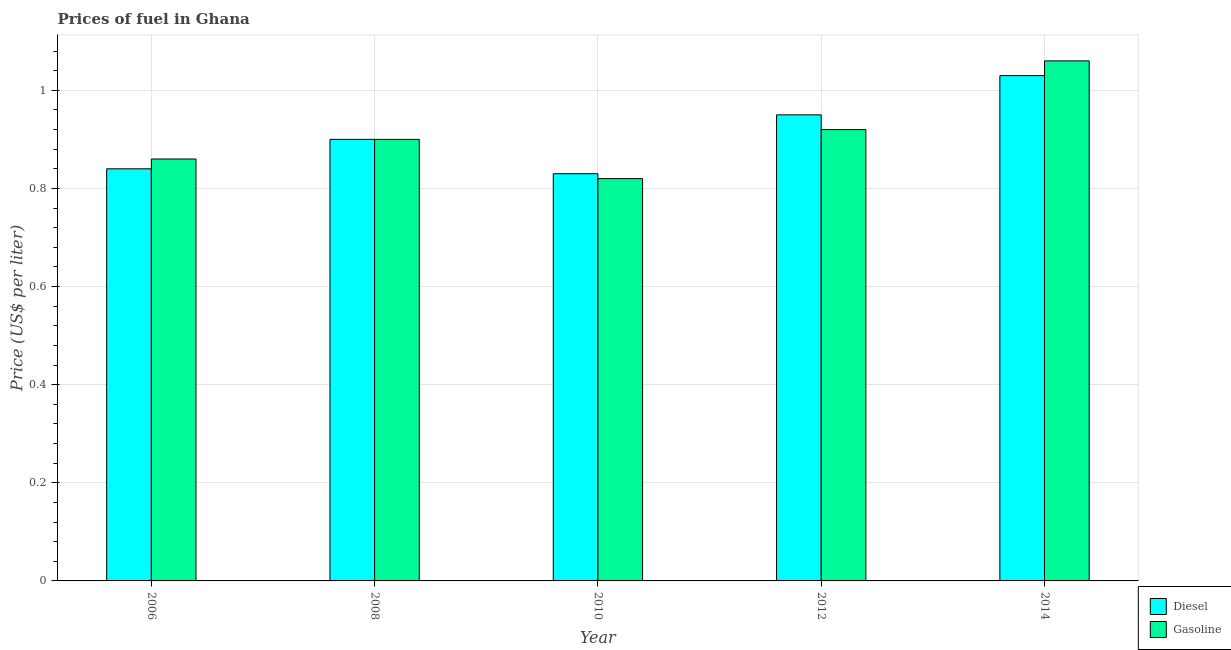Are the number of bars on each tick of the X-axis equal?
Make the answer very short. Yes. How many bars are there on the 2nd tick from the left?
Provide a short and direct response. 2. How many bars are there on the 5th tick from the right?
Your response must be concise. 2. What is the gasoline price in 2014?
Make the answer very short. 1.06. Across all years, what is the maximum gasoline price?
Provide a short and direct response. 1.06. Across all years, what is the minimum gasoline price?
Keep it short and to the point. 0.82. What is the total gasoline price in the graph?
Make the answer very short. 4.56. What is the difference between the diesel price in 2010 and that in 2012?
Ensure brevity in your answer.  -0.12. What is the difference between the gasoline price in 2006 and the diesel price in 2014?
Provide a short and direct response. -0.2. What is the average diesel price per year?
Make the answer very short. 0.91. In the year 2008, what is the difference between the diesel price and gasoline price?
Offer a terse response. 0. What is the ratio of the diesel price in 2010 to that in 2014?
Your response must be concise. 0.81. What is the difference between the highest and the second highest gasoline price?
Your answer should be very brief. 0.14. What is the difference between the highest and the lowest diesel price?
Make the answer very short. 0.2. In how many years, is the diesel price greater than the average diesel price taken over all years?
Offer a terse response. 2. Is the sum of the diesel price in 2012 and 2014 greater than the maximum gasoline price across all years?
Your response must be concise. Yes. What does the 1st bar from the left in 2010 represents?
Provide a short and direct response. Diesel. What does the 1st bar from the right in 2014 represents?
Offer a very short reply. Gasoline. How many bars are there?
Provide a short and direct response. 10. Are all the bars in the graph horizontal?
Make the answer very short. No. Does the graph contain grids?
Your answer should be compact. Yes. Where does the legend appear in the graph?
Offer a terse response. Bottom right. How are the legend labels stacked?
Your response must be concise. Vertical. What is the title of the graph?
Offer a terse response. Prices of fuel in Ghana. Does "Investment in Transport" appear as one of the legend labels in the graph?
Ensure brevity in your answer.  No. What is the label or title of the Y-axis?
Your response must be concise. Price (US$ per liter). What is the Price (US$ per liter) in Diesel in 2006?
Ensure brevity in your answer.  0.84. What is the Price (US$ per liter) in Gasoline in 2006?
Your answer should be compact. 0.86. What is the Price (US$ per liter) in Diesel in 2008?
Keep it short and to the point. 0.9. What is the Price (US$ per liter) in Gasoline in 2008?
Offer a very short reply. 0.9. What is the Price (US$ per liter) in Diesel in 2010?
Provide a short and direct response. 0.83. What is the Price (US$ per liter) of Gasoline in 2010?
Provide a succinct answer. 0.82. What is the Price (US$ per liter) in Gasoline in 2012?
Your answer should be very brief. 0.92. What is the Price (US$ per liter) of Gasoline in 2014?
Your response must be concise. 1.06. Across all years, what is the maximum Price (US$ per liter) in Diesel?
Give a very brief answer. 1.03. Across all years, what is the maximum Price (US$ per liter) of Gasoline?
Ensure brevity in your answer.  1.06. Across all years, what is the minimum Price (US$ per liter) of Diesel?
Provide a short and direct response. 0.83. Across all years, what is the minimum Price (US$ per liter) in Gasoline?
Keep it short and to the point. 0.82. What is the total Price (US$ per liter) in Diesel in the graph?
Your response must be concise. 4.55. What is the total Price (US$ per liter) in Gasoline in the graph?
Your answer should be compact. 4.56. What is the difference between the Price (US$ per liter) of Diesel in 2006 and that in 2008?
Your answer should be very brief. -0.06. What is the difference between the Price (US$ per liter) in Gasoline in 2006 and that in 2008?
Keep it short and to the point. -0.04. What is the difference between the Price (US$ per liter) of Diesel in 2006 and that in 2010?
Your answer should be very brief. 0.01. What is the difference between the Price (US$ per liter) of Diesel in 2006 and that in 2012?
Provide a succinct answer. -0.11. What is the difference between the Price (US$ per liter) in Gasoline in 2006 and that in 2012?
Your response must be concise. -0.06. What is the difference between the Price (US$ per liter) in Diesel in 2006 and that in 2014?
Offer a very short reply. -0.19. What is the difference between the Price (US$ per liter) of Diesel in 2008 and that in 2010?
Ensure brevity in your answer.  0.07. What is the difference between the Price (US$ per liter) in Gasoline in 2008 and that in 2012?
Your response must be concise. -0.02. What is the difference between the Price (US$ per liter) of Diesel in 2008 and that in 2014?
Make the answer very short. -0.13. What is the difference between the Price (US$ per liter) in Gasoline in 2008 and that in 2014?
Offer a terse response. -0.16. What is the difference between the Price (US$ per liter) of Diesel in 2010 and that in 2012?
Offer a terse response. -0.12. What is the difference between the Price (US$ per liter) of Gasoline in 2010 and that in 2014?
Your answer should be very brief. -0.24. What is the difference between the Price (US$ per liter) of Diesel in 2012 and that in 2014?
Offer a very short reply. -0.08. What is the difference between the Price (US$ per liter) of Gasoline in 2012 and that in 2014?
Your answer should be very brief. -0.14. What is the difference between the Price (US$ per liter) in Diesel in 2006 and the Price (US$ per liter) in Gasoline in 2008?
Provide a succinct answer. -0.06. What is the difference between the Price (US$ per liter) of Diesel in 2006 and the Price (US$ per liter) of Gasoline in 2010?
Your answer should be very brief. 0.02. What is the difference between the Price (US$ per liter) in Diesel in 2006 and the Price (US$ per liter) in Gasoline in 2012?
Offer a very short reply. -0.08. What is the difference between the Price (US$ per liter) of Diesel in 2006 and the Price (US$ per liter) of Gasoline in 2014?
Offer a terse response. -0.22. What is the difference between the Price (US$ per liter) in Diesel in 2008 and the Price (US$ per liter) in Gasoline in 2012?
Your response must be concise. -0.02. What is the difference between the Price (US$ per liter) in Diesel in 2008 and the Price (US$ per liter) in Gasoline in 2014?
Offer a very short reply. -0.16. What is the difference between the Price (US$ per liter) of Diesel in 2010 and the Price (US$ per liter) of Gasoline in 2012?
Your answer should be very brief. -0.09. What is the difference between the Price (US$ per liter) in Diesel in 2010 and the Price (US$ per liter) in Gasoline in 2014?
Offer a very short reply. -0.23. What is the difference between the Price (US$ per liter) of Diesel in 2012 and the Price (US$ per liter) of Gasoline in 2014?
Ensure brevity in your answer.  -0.11. What is the average Price (US$ per liter) in Diesel per year?
Offer a terse response. 0.91. What is the average Price (US$ per liter) in Gasoline per year?
Keep it short and to the point. 0.91. In the year 2006, what is the difference between the Price (US$ per liter) of Diesel and Price (US$ per liter) of Gasoline?
Your answer should be very brief. -0.02. In the year 2008, what is the difference between the Price (US$ per liter) in Diesel and Price (US$ per liter) in Gasoline?
Make the answer very short. 0. In the year 2010, what is the difference between the Price (US$ per liter) in Diesel and Price (US$ per liter) in Gasoline?
Your answer should be compact. 0.01. In the year 2014, what is the difference between the Price (US$ per liter) in Diesel and Price (US$ per liter) in Gasoline?
Provide a short and direct response. -0.03. What is the ratio of the Price (US$ per liter) in Gasoline in 2006 to that in 2008?
Give a very brief answer. 0.96. What is the ratio of the Price (US$ per liter) of Gasoline in 2006 to that in 2010?
Give a very brief answer. 1.05. What is the ratio of the Price (US$ per liter) in Diesel in 2006 to that in 2012?
Keep it short and to the point. 0.88. What is the ratio of the Price (US$ per liter) of Gasoline in 2006 to that in 2012?
Give a very brief answer. 0.93. What is the ratio of the Price (US$ per liter) of Diesel in 2006 to that in 2014?
Make the answer very short. 0.82. What is the ratio of the Price (US$ per liter) of Gasoline in 2006 to that in 2014?
Give a very brief answer. 0.81. What is the ratio of the Price (US$ per liter) of Diesel in 2008 to that in 2010?
Provide a short and direct response. 1.08. What is the ratio of the Price (US$ per liter) of Gasoline in 2008 to that in 2010?
Your answer should be very brief. 1.1. What is the ratio of the Price (US$ per liter) of Diesel in 2008 to that in 2012?
Give a very brief answer. 0.95. What is the ratio of the Price (US$ per liter) in Gasoline in 2008 to that in 2012?
Make the answer very short. 0.98. What is the ratio of the Price (US$ per liter) in Diesel in 2008 to that in 2014?
Make the answer very short. 0.87. What is the ratio of the Price (US$ per liter) in Gasoline in 2008 to that in 2014?
Provide a succinct answer. 0.85. What is the ratio of the Price (US$ per liter) in Diesel in 2010 to that in 2012?
Give a very brief answer. 0.87. What is the ratio of the Price (US$ per liter) in Gasoline in 2010 to that in 2012?
Offer a terse response. 0.89. What is the ratio of the Price (US$ per liter) in Diesel in 2010 to that in 2014?
Your answer should be compact. 0.81. What is the ratio of the Price (US$ per liter) in Gasoline in 2010 to that in 2014?
Keep it short and to the point. 0.77. What is the ratio of the Price (US$ per liter) of Diesel in 2012 to that in 2014?
Your answer should be very brief. 0.92. What is the ratio of the Price (US$ per liter) of Gasoline in 2012 to that in 2014?
Your answer should be compact. 0.87. What is the difference between the highest and the second highest Price (US$ per liter) of Diesel?
Provide a short and direct response. 0.08. What is the difference between the highest and the second highest Price (US$ per liter) in Gasoline?
Your answer should be very brief. 0.14. What is the difference between the highest and the lowest Price (US$ per liter) in Diesel?
Give a very brief answer. 0.2. What is the difference between the highest and the lowest Price (US$ per liter) in Gasoline?
Your answer should be very brief. 0.24. 